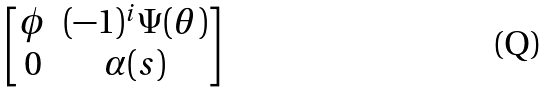Convert formula to latex. <formula><loc_0><loc_0><loc_500><loc_500>\begin{bmatrix} \phi & ( - 1 ) ^ { i } \Psi ( \theta ) \\ 0 & \alpha ( s ) \end{bmatrix}</formula> 